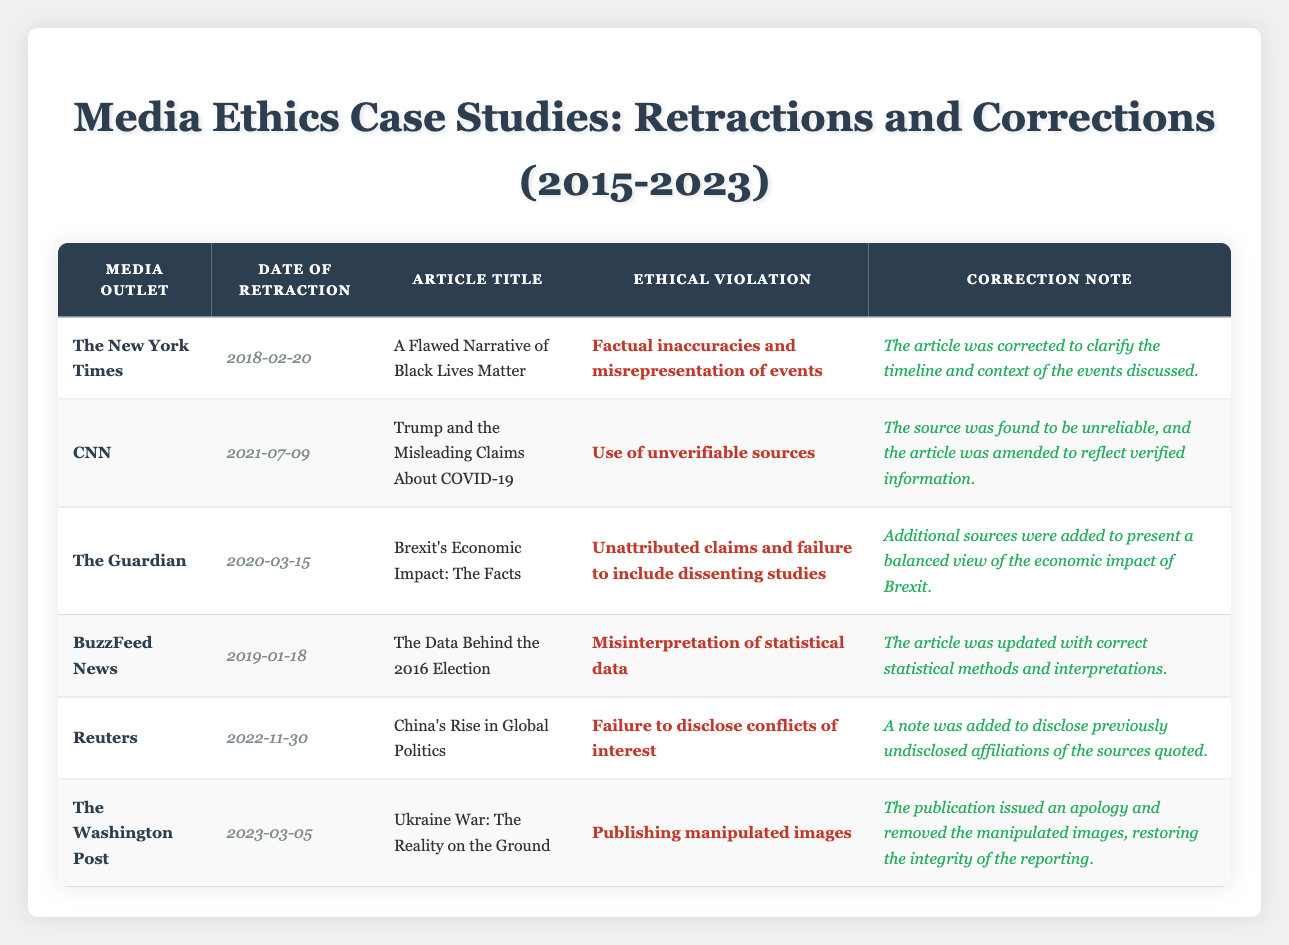What media outlet issued a retraction on February 20, 2018? By scanning the "Date of Retraction" column for the date "2018-02-20," we find that "The New York Times" is listed.
Answer: The New York Times How many articles were retracted by CNN? Looking at the table, there is one entry for CNN showing a retraction, specifically for the article titled "Trump and the Misleading Claims About COVID-19."
Answer: One Which article had an ethical violation related to conflicts of interest? Reviewing the "Ethical Violation" column, the article titled "China's Rise in Global Politics" by Reuters was retracted due to a "Failure to disclose conflicts of interest."
Answer: China's Rise in Global Politics Is it true that BuzzFeed News published an article with misrepresentations? The article by BuzzFeed News titled "The Data Behind the 2016 Election" was retracted due to the "Misinterpretation of statistical data," which indicates it was related to misrepresentation.
Answer: True What is the correction note for the article "A Flawed Narrative of Black Lives Matter"? The correction note provided for this article indicates that "The article was corrected to clarify the timeline and context of the events discussed."
Answer: The article was corrected to clarify the timeline and context of the events discussed Which media outlet had the most recent retraction? To find this, we check the "Date of Retraction" column, and see that "The Washington Post" retracted an article on March 5, 2023, which is the latest date in the table.
Answer: The Washington Post How many articles were corrected for unattributed claims? By scanning through the entries, we look for articles related to unattributed claims. Only "Brexit's Economic Impact: The Facts" published by The Guardian had this violation, leading to only one such incident.
Answer: One Which articles were retreated due to the use of unverifiable sources? Checking the relevant rows in the table, the only article that falls under this category is "Trump and the Misleading Claims About COVID-19" by CNN. So there is one article.
Answer: One What ethical violation was associated with the article published by The Washington Post? The row for "Ukraine War: The Reality on the Ground" indicates that the ethical violation was "Publishing manipulated images."
Answer: Publishing manipulated images 